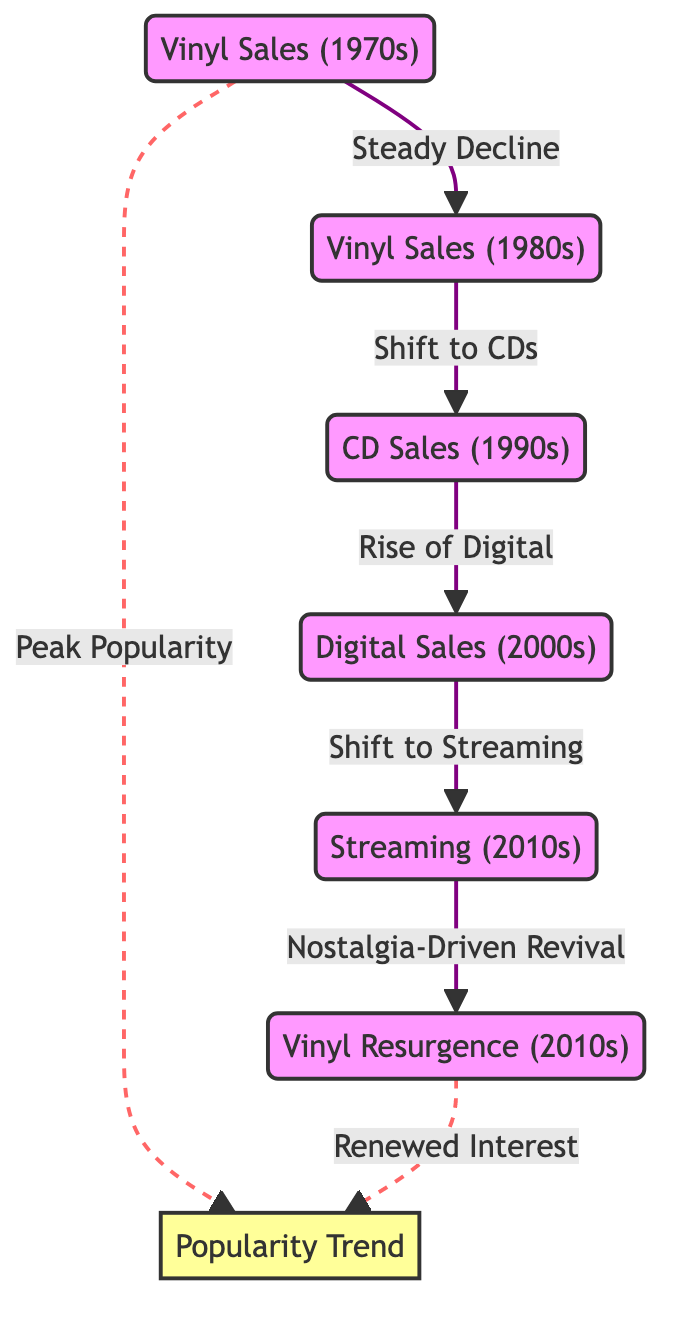What sales trend is shown from the 1970s to the 1980s? The diagram indicates a "Steady Decline" in vinyl sales from the 1970s to the 1980s, as illustrated by the connecting arrow between the two nodes.
Answer: Steady Decline What format experienced a rise in the 1990s according to the diagram? The diagram shows that "CD Sales" rose in the 1990s, indicated by the arrow leading from vinyl sales in the 1980s to CD sales in the 1990s.
Answer: CD Sales What major shift occurred in the 2000s? The diagram describes a transition to "Digital Sales" in the 2000s, which follows the increase of CD sales in the 1990s and is depicted by an arrow.
Answer: Digital Sales How are vinyl sales in the 2010s represented in the diagram? The diagram features "Vinyl Resurgence" in the 2010s, which is linked to "Nostalgia-Driven Revival" and indicates a renewed interest in vinyl.
Answer: Vinyl Resurgence What do the dashed arrows connecting vinyl sales in the 1970s and the 2010s indicate? The dashed arrows represent non-linear trends, specifically showing "Peak Popularity" for the 1970s and "Renewed Interest" for the 2010s, highlighting their significance in the popularity trend.
Answer: Peak Popularity, Renewed Interest How many nodes represent sales formats in the diagram? There are five distinct nodes that represent different sales formats over the decades, linked by arrows to indicate trends.
Answer: Five What was the relationship between digital sales in the 2000s and streaming in the 2010s? The diagram depicts a linear relationship showing a "Shift to Streaming" from digital sales in the 2000s, indicating a transition in music consumption formats.
Answer: Shift to Streaming What is the overall trend in music format popularity depicted in the diagram? The overall trend showcases a decline in physical format popularity (vinyl to CDs) followed by a rise in digital formats (to streaming), later culminating in a resurgence of vinyl driven by nostalgia.
Answer: Decline and Resurgence 